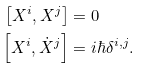<formula> <loc_0><loc_0><loc_500><loc_500>\left [ X ^ { i } , X ^ { j } \right ] & = 0 \\ \left [ X ^ { i } , \dot { X } ^ { j } \right ] & = i \hbar { \delta } ^ { i , j } .</formula> 